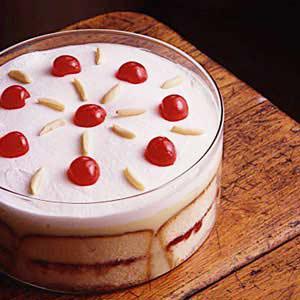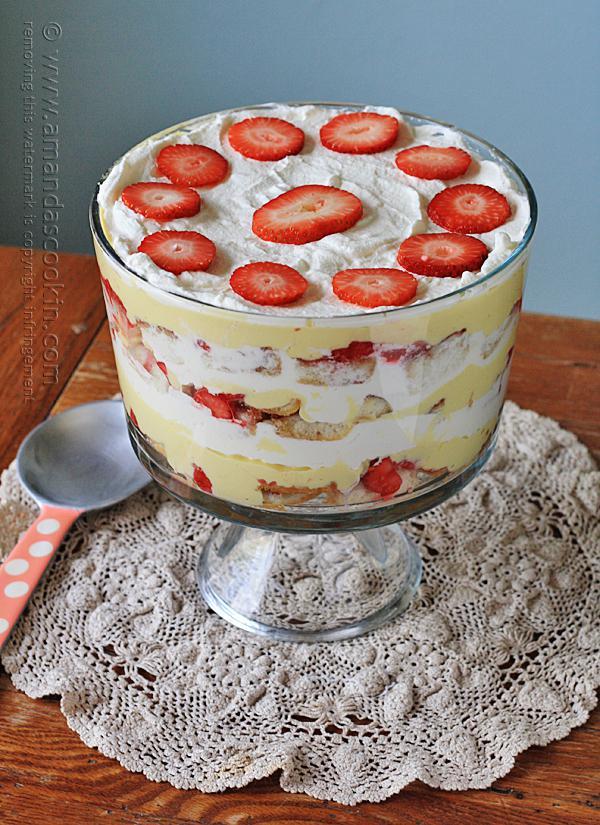The first image is the image on the left, the second image is the image on the right. Assess this claim about the two images: "One image shows a dessert topped with sliced, non-heaped strawberries, and the other shows a dessert topped with a different kind of small bright red fruit.". Correct or not? Answer yes or no. Yes. The first image is the image on the left, the second image is the image on the right. Considering the images on both sides, is "A single dessert in the image on the left has a glass pedestal." valid? Answer yes or no. No. 